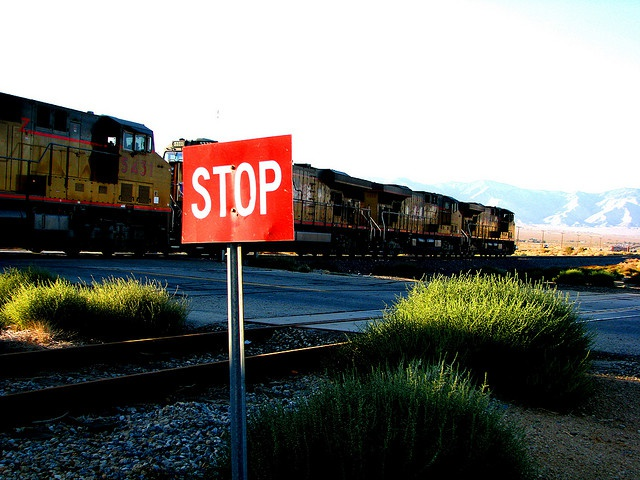Describe the objects in this image and their specific colors. I can see train in white, black, olive, maroon, and navy tones, train in white, black, gray, olive, and maroon tones, and stop sign in white, red, and salmon tones in this image. 